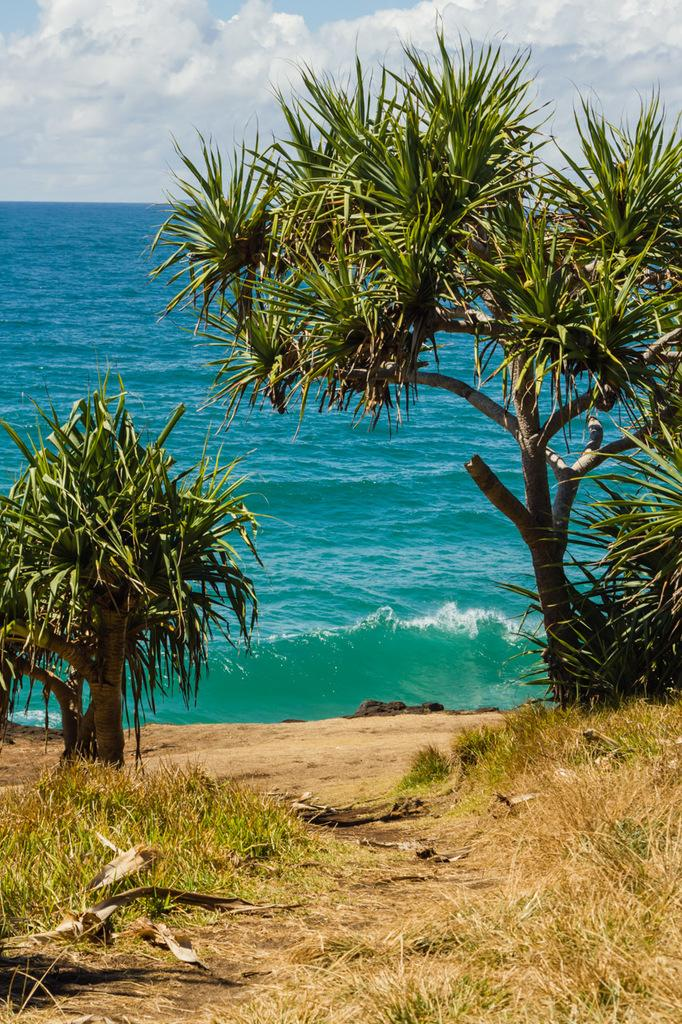What type of vegetation can be seen in the image? There are trees in the image. How would you describe the color of the water in the image? The water in the image has blue and green colors. What is the condition of the grass in front of the trees? The grass in front of the trees is dry. What can be seen in the sky in the image? The sky is visible in the image and has white and blue colors. What type of wrench is being used to tighten the string in the image? There is no wrench or string present in the image; it features trees, water, dry grass, and a sky with white and blue colors. 